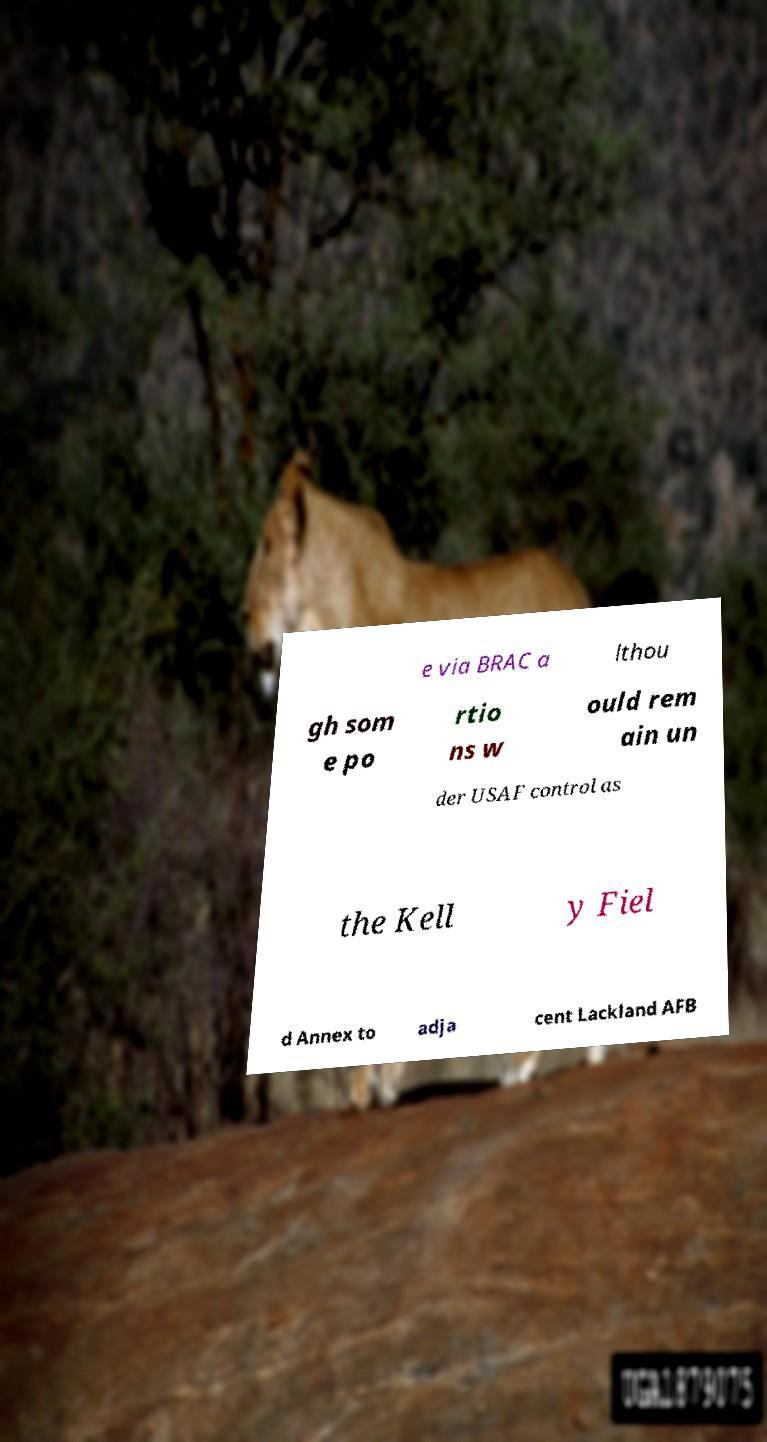Could you extract and type out the text from this image? e via BRAC a lthou gh som e po rtio ns w ould rem ain un der USAF control as the Kell y Fiel d Annex to adja cent Lackland AFB 